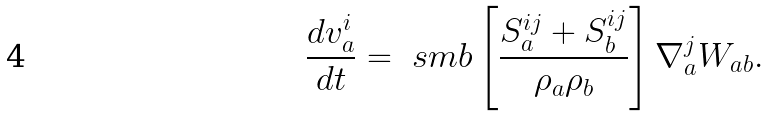<formula> <loc_0><loc_0><loc_500><loc_500>\frac { d v ^ { i } _ { a } } { d t } = \ s m b \left [ \frac { S ^ { i j } _ { a } + S ^ { i j } _ { b } } { \rho _ { a } \rho _ { b } } \right ] \nabla ^ { j } _ { a } W _ { a b } .</formula> 